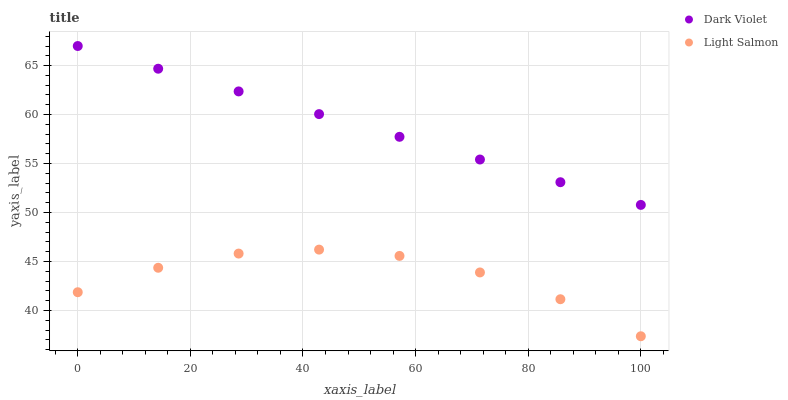Does Light Salmon have the minimum area under the curve?
Answer yes or no. Yes. Does Dark Violet have the maximum area under the curve?
Answer yes or no. Yes. Does Dark Violet have the minimum area under the curve?
Answer yes or no. No. Is Dark Violet the smoothest?
Answer yes or no. Yes. Is Light Salmon the roughest?
Answer yes or no. Yes. Is Dark Violet the roughest?
Answer yes or no. No. Does Light Salmon have the lowest value?
Answer yes or no. Yes. Does Dark Violet have the lowest value?
Answer yes or no. No. Does Dark Violet have the highest value?
Answer yes or no. Yes. Is Light Salmon less than Dark Violet?
Answer yes or no. Yes. Is Dark Violet greater than Light Salmon?
Answer yes or no. Yes. Does Light Salmon intersect Dark Violet?
Answer yes or no. No. 